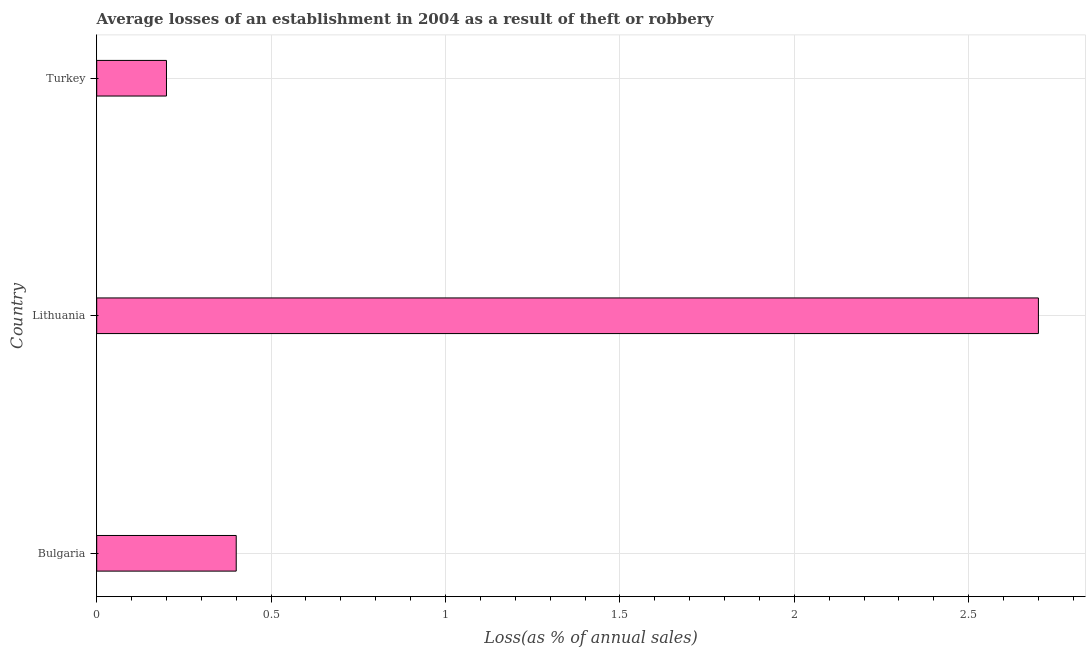Does the graph contain any zero values?
Provide a succinct answer. No. Does the graph contain grids?
Make the answer very short. Yes. What is the title of the graph?
Your answer should be very brief. Average losses of an establishment in 2004 as a result of theft or robbery. What is the label or title of the X-axis?
Your answer should be very brief. Loss(as % of annual sales). What is the label or title of the Y-axis?
Provide a short and direct response. Country. In which country was the losses due to theft maximum?
Provide a succinct answer. Lithuania. What is the sum of the losses due to theft?
Provide a succinct answer. 3.3. In how many countries, is the losses due to theft greater than 2.5 %?
Ensure brevity in your answer.  1. What is the ratio of the losses due to theft in Lithuania to that in Turkey?
Offer a very short reply. 13.5. Is the losses due to theft in Bulgaria less than that in Turkey?
Provide a succinct answer. No. What is the difference between the highest and the second highest losses due to theft?
Offer a terse response. 2.3. In how many countries, is the losses due to theft greater than the average losses due to theft taken over all countries?
Provide a short and direct response. 1. How many bars are there?
Your answer should be very brief. 3. How many countries are there in the graph?
Make the answer very short. 3. What is the difference between two consecutive major ticks on the X-axis?
Provide a short and direct response. 0.5. Are the values on the major ticks of X-axis written in scientific E-notation?
Ensure brevity in your answer.  No. What is the difference between the Loss(as % of annual sales) in Bulgaria and Lithuania?
Make the answer very short. -2.3. What is the ratio of the Loss(as % of annual sales) in Bulgaria to that in Lithuania?
Your answer should be very brief. 0.15. What is the ratio of the Loss(as % of annual sales) in Bulgaria to that in Turkey?
Keep it short and to the point. 2. What is the ratio of the Loss(as % of annual sales) in Lithuania to that in Turkey?
Offer a very short reply. 13.5. 